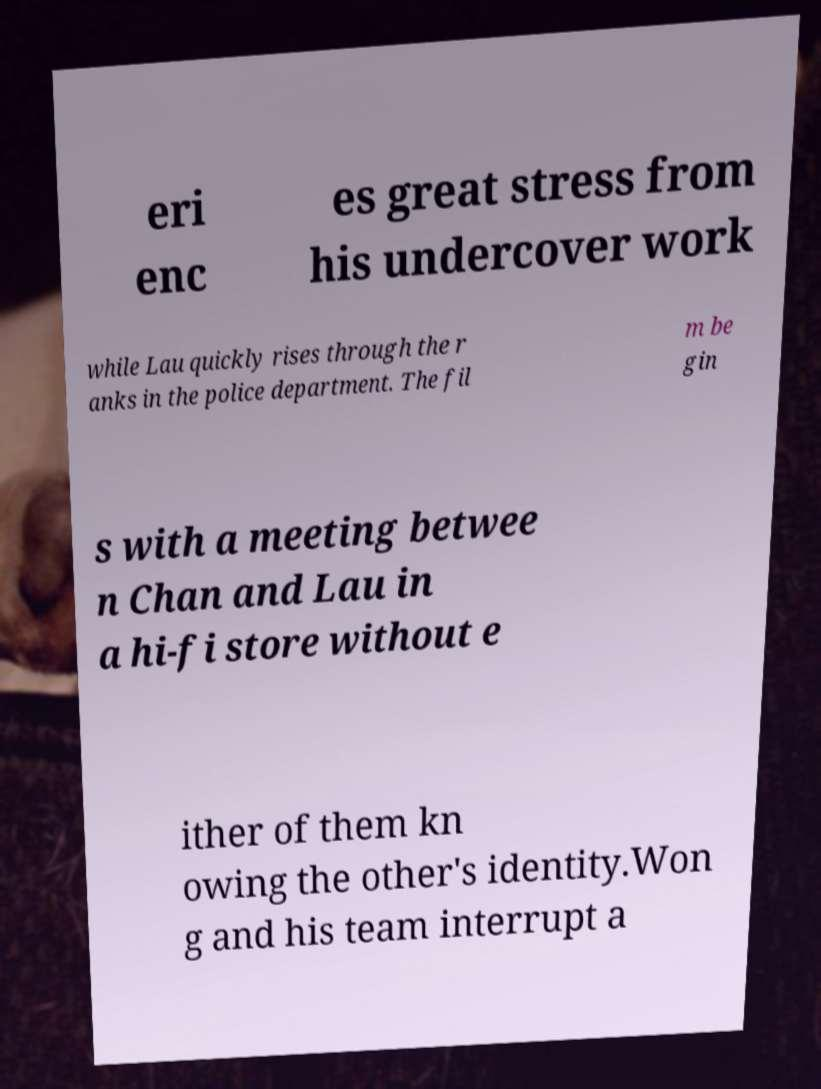I need the written content from this picture converted into text. Can you do that? eri enc es great stress from his undercover work while Lau quickly rises through the r anks in the police department. The fil m be gin s with a meeting betwee n Chan and Lau in a hi-fi store without e ither of them kn owing the other's identity.Won g and his team interrupt a 